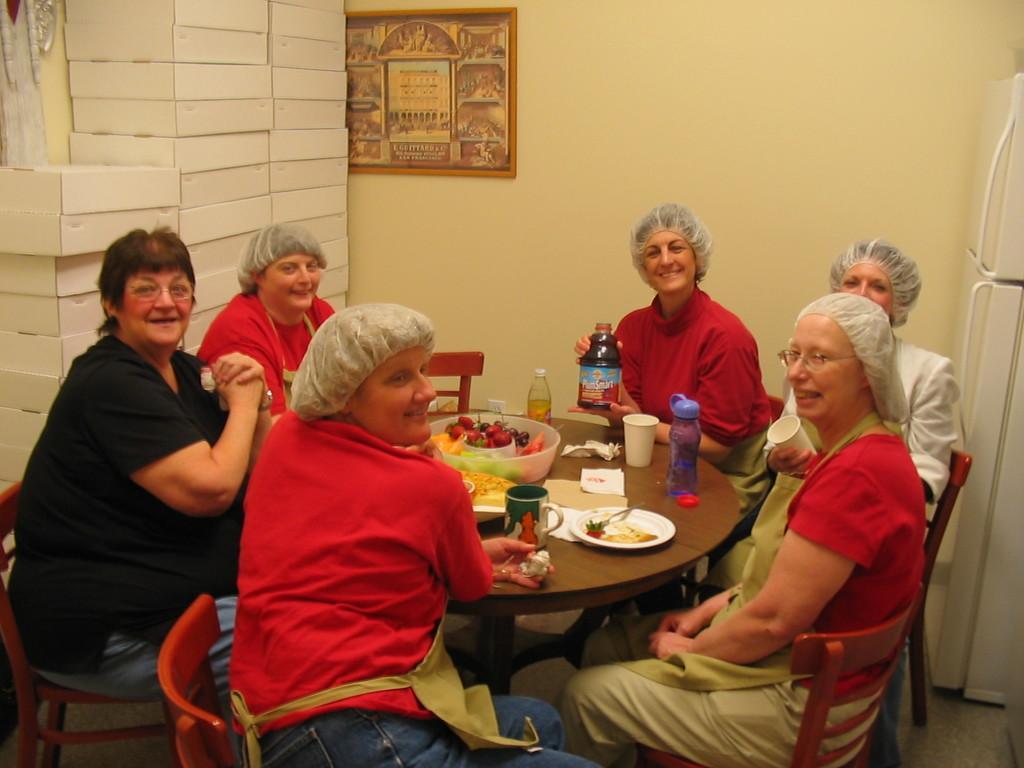Please provide a concise description of this image. This picture is clicked inside the room. Here are six women sitting on a chair around the table and this table contains water bottle, glass, plate, spoon, tissue, cup, bowl with fruits. Behind them, we have a wall on which a photo frame is placed on it and on the right corner of this picture, we have a refrigerator. On the left corner of this picture, we have many cotton boxes. 